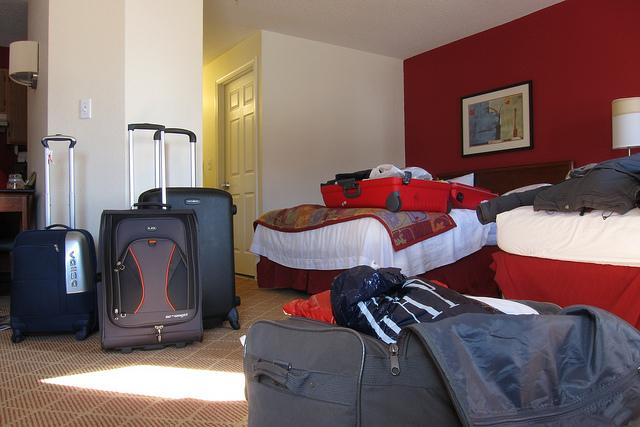Are the people in this room leaving the hotel?
Concise answer only. Yes. Why are there so many suitcases?
Be succinct. Family vacation. Is this a hotel room?
Concise answer only. Yes. 